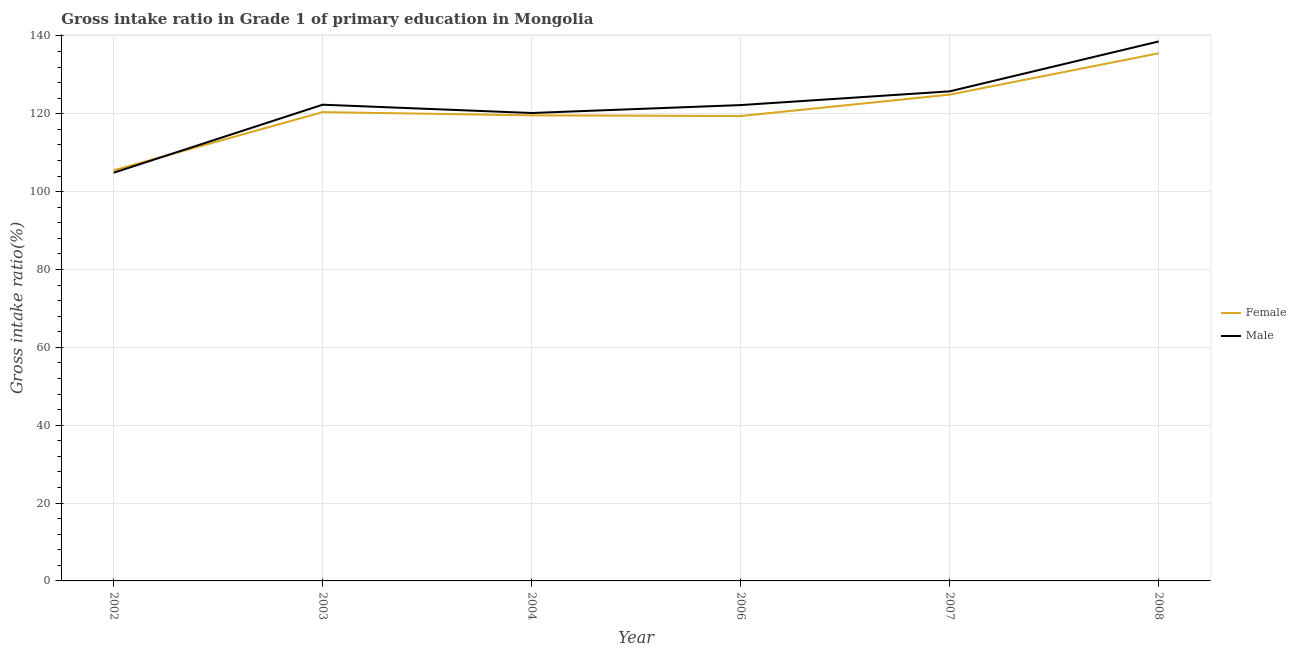How many different coloured lines are there?
Provide a short and direct response. 2. What is the gross intake ratio(male) in 2003?
Offer a terse response. 122.34. Across all years, what is the maximum gross intake ratio(male)?
Offer a terse response. 138.6. Across all years, what is the minimum gross intake ratio(male)?
Provide a short and direct response. 104.86. In which year was the gross intake ratio(female) maximum?
Ensure brevity in your answer.  2008. What is the total gross intake ratio(female) in the graph?
Ensure brevity in your answer.  725.45. What is the difference between the gross intake ratio(male) in 2002 and that in 2007?
Offer a very short reply. -20.91. What is the difference between the gross intake ratio(female) in 2008 and the gross intake ratio(male) in 2002?
Your answer should be compact. 30.69. What is the average gross intake ratio(male) per year?
Make the answer very short. 122.34. In the year 2004, what is the difference between the gross intake ratio(male) and gross intake ratio(female)?
Offer a terse response. 0.6. In how many years, is the gross intake ratio(female) greater than 100 %?
Ensure brevity in your answer.  6. What is the ratio of the gross intake ratio(male) in 2002 to that in 2003?
Your answer should be compact. 0.86. What is the difference between the highest and the second highest gross intake ratio(female)?
Give a very brief answer. 10.62. What is the difference between the highest and the lowest gross intake ratio(male)?
Provide a short and direct response. 33.73. In how many years, is the gross intake ratio(female) greater than the average gross intake ratio(female) taken over all years?
Provide a short and direct response. 2. Is the sum of the gross intake ratio(female) in 2006 and 2007 greater than the maximum gross intake ratio(male) across all years?
Offer a very short reply. Yes. Does the gross intake ratio(female) monotonically increase over the years?
Offer a terse response. No. Is the gross intake ratio(female) strictly greater than the gross intake ratio(male) over the years?
Give a very brief answer. No. Are the values on the major ticks of Y-axis written in scientific E-notation?
Give a very brief answer. No. Where does the legend appear in the graph?
Your response must be concise. Center right. How are the legend labels stacked?
Keep it short and to the point. Vertical. What is the title of the graph?
Offer a very short reply. Gross intake ratio in Grade 1 of primary education in Mongolia. What is the label or title of the X-axis?
Your response must be concise. Year. What is the label or title of the Y-axis?
Make the answer very short. Gross intake ratio(%). What is the Gross intake ratio(%) of Female in 2002?
Your answer should be very brief. 105.49. What is the Gross intake ratio(%) of Male in 2002?
Offer a terse response. 104.86. What is the Gross intake ratio(%) of Female in 2003?
Offer a very short reply. 120.43. What is the Gross intake ratio(%) in Male in 2003?
Keep it short and to the point. 122.34. What is the Gross intake ratio(%) of Female in 2004?
Your response must be concise. 119.61. What is the Gross intake ratio(%) in Male in 2004?
Your answer should be compact. 120.21. What is the Gross intake ratio(%) of Female in 2006?
Your answer should be compact. 119.43. What is the Gross intake ratio(%) of Male in 2006?
Ensure brevity in your answer.  122.25. What is the Gross intake ratio(%) of Female in 2007?
Offer a very short reply. 124.93. What is the Gross intake ratio(%) in Male in 2007?
Your answer should be very brief. 125.78. What is the Gross intake ratio(%) of Female in 2008?
Offer a very short reply. 135.55. What is the Gross intake ratio(%) of Male in 2008?
Offer a terse response. 138.6. Across all years, what is the maximum Gross intake ratio(%) of Female?
Offer a very short reply. 135.55. Across all years, what is the maximum Gross intake ratio(%) in Male?
Keep it short and to the point. 138.6. Across all years, what is the minimum Gross intake ratio(%) in Female?
Offer a very short reply. 105.49. Across all years, what is the minimum Gross intake ratio(%) in Male?
Provide a short and direct response. 104.86. What is the total Gross intake ratio(%) in Female in the graph?
Give a very brief answer. 725.45. What is the total Gross intake ratio(%) in Male in the graph?
Your response must be concise. 734.04. What is the difference between the Gross intake ratio(%) in Female in 2002 and that in 2003?
Provide a short and direct response. -14.95. What is the difference between the Gross intake ratio(%) in Male in 2002 and that in 2003?
Your answer should be compact. -17.48. What is the difference between the Gross intake ratio(%) of Female in 2002 and that in 2004?
Ensure brevity in your answer.  -14.12. What is the difference between the Gross intake ratio(%) of Male in 2002 and that in 2004?
Your answer should be compact. -15.35. What is the difference between the Gross intake ratio(%) in Female in 2002 and that in 2006?
Ensure brevity in your answer.  -13.95. What is the difference between the Gross intake ratio(%) of Male in 2002 and that in 2006?
Provide a short and direct response. -17.38. What is the difference between the Gross intake ratio(%) in Female in 2002 and that in 2007?
Your answer should be very brief. -19.44. What is the difference between the Gross intake ratio(%) of Male in 2002 and that in 2007?
Ensure brevity in your answer.  -20.91. What is the difference between the Gross intake ratio(%) in Female in 2002 and that in 2008?
Offer a terse response. -30.07. What is the difference between the Gross intake ratio(%) in Male in 2002 and that in 2008?
Your answer should be very brief. -33.73. What is the difference between the Gross intake ratio(%) in Female in 2003 and that in 2004?
Your answer should be compact. 0.82. What is the difference between the Gross intake ratio(%) in Male in 2003 and that in 2004?
Keep it short and to the point. 2.13. What is the difference between the Gross intake ratio(%) of Male in 2003 and that in 2006?
Provide a succinct answer. 0.1. What is the difference between the Gross intake ratio(%) of Female in 2003 and that in 2007?
Offer a very short reply. -4.49. What is the difference between the Gross intake ratio(%) in Male in 2003 and that in 2007?
Ensure brevity in your answer.  -3.43. What is the difference between the Gross intake ratio(%) of Female in 2003 and that in 2008?
Keep it short and to the point. -15.12. What is the difference between the Gross intake ratio(%) in Male in 2003 and that in 2008?
Give a very brief answer. -16.25. What is the difference between the Gross intake ratio(%) in Female in 2004 and that in 2006?
Keep it short and to the point. 0.18. What is the difference between the Gross intake ratio(%) of Male in 2004 and that in 2006?
Make the answer very short. -2.04. What is the difference between the Gross intake ratio(%) of Female in 2004 and that in 2007?
Provide a short and direct response. -5.32. What is the difference between the Gross intake ratio(%) of Male in 2004 and that in 2007?
Make the answer very short. -5.57. What is the difference between the Gross intake ratio(%) of Female in 2004 and that in 2008?
Your answer should be very brief. -15.94. What is the difference between the Gross intake ratio(%) of Male in 2004 and that in 2008?
Your response must be concise. -18.39. What is the difference between the Gross intake ratio(%) in Female in 2006 and that in 2007?
Provide a short and direct response. -5.5. What is the difference between the Gross intake ratio(%) in Male in 2006 and that in 2007?
Make the answer very short. -3.53. What is the difference between the Gross intake ratio(%) of Female in 2006 and that in 2008?
Give a very brief answer. -16.12. What is the difference between the Gross intake ratio(%) in Male in 2006 and that in 2008?
Provide a short and direct response. -16.35. What is the difference between the Gross intake ratio(%) of Female in 2007 and that in 2008?
Keep it short and to the point. -10.62. What is the difference between the Gross intake ratio(%) in Male in 2007 and that in 2008?
Provide a short and direct response. -12.82. What is the difference between the Gross intake ratio(%) in Female in 2002 and the Gross intake ratio(%) in Male in 2003?
Keep it short and to the point. -16.86. What is the difference between the Gross intake ratio(%) of Female in 2002 and the Gross intake ratio(%) of Male in 2004?
Ensure brevity in your answer.  -14.72. What is the difference between the Gross intake ratio(%) of Female in 2002 and the Gross intake ratio(%) of Male in 2006?
Your answer should be compact. -16.76. What is the difference between the Gross intake ratio(%) of Female in 2002 and the Gross intake ratio(%) of Male in 2007?
Make the answer very short. -20.29. What is the difference between the Gross intake ratio(%) of Female in 2002 and the Gross intake ratio(%) of Male in 2008?
Give a very brief answer. -33.11. What is the difference between the Gross intake ratio(%) in Female in 2003 and the Gross intake ratio(%) in Male in 2004?
Provide a succinct answer. 0.22. What is the difference between the Gross intake ratio(%) in Female in 2003 and the Gross intake ratio(%) in Male in 2006?
Make the answer very short. -1.81. What is the difference between the Gross intake ratio(%) of Female in 2003 and the Gross intake ratio(%) of Male in 2007?
Your response must be concise. -5.34. What is the difference between the Gross intake ratio(%) in Female in 2003 and the Gross intake ratio(%) in Male in 2008?
Give a very brief answer. -18.16. What is the difference between the Gross intake ratio(%) in Female in 2004 and the Gross intake ratio(%) in Male in 2006?
Your response must be concise. -2.64. What is the difference between the Gross intake ratio(%) of Female in 2004 and the Gross intake ratio(%) of Male in 2007?
Offer a terse response. -6.17. What is the difference between the Gross intake ratio(%) of Female in 2004 and the Gross intake ratio(%) of Male in 2008?
Your answer should be very brief. -18.98. What is the difference between the Gross intake ratio(%) of Female in 2006 and the Gross intake ratio(%) of Male in 2007?
Make the answer very short. -6.34. What is the difference between the Gross intake ratio(%) in Female in 2006 and the Gross intake ratio(%) in Male in 2008?
Keep it short and to the point. -19.16. What is the difference between the Gross intake ratio(%) of Female in 2007 and the Gross intake ratio(%) of Male in 2008?
Ensure brevity in your answer.  -13.67. What is the average Gross intake ratio(%) in Female per year?
Your answer should be very brief. 120.91. What is the average Gross intake ratio(%) of Male per year?
Keep it short and to the point. 122.34. In the year 2002, what is the difference between the Gross intake ratio(%) in Female and Gross intake ratio(%) in Male?
Give a very brief answer. 0.62. In the year 2003, what is the difference between the Gross intake ratio(%) of Female and Gross intake ratio(%) of Male?
Offer a very short reply. -1.91. In the year 2004, what is the difference between the Gross intake ratio(%) of Female and Gross intake ratio(%) of Male?
Make the answer very short. -0.6. In the year 2006, what is the difference between the Gross intake ratio(%) in Female and Gross intake ratio(%) in Male?
Give a very brief answer. -2.81. In the year 2007, what is the difference between the Gross intake ratio(%) of Female and Gross intake ratio(%) of Male?
Your response must be concise. -0.85. In the year 2008, what is the difference between the Gross intake ratio(%) of Female and Gross intake ratio(%) of Male?
Offer a terse response. -3.04. What is the ratio of the Gross intake ratio(%) of Female in 2002 to that in 2003?
Ensure brevity in your answer.  0.88. What is the ratio of the Gross intake ratio(%) in Female in 2002 to that in 2004?
Provide a succinct answer. 0.88. What is the ratio of the Gross intake ratio(%) of Male in 2002 to that in 2004?
Provide a succinct answer. 0.87. What is the ratio of the Gross intake ratio(%) of Female in 2002 to that in 2006?
Give a very brief answer. 0.88. What is the ratio of the Gross intake ratio(%) of Male in 2002 to that in 2006?
Ensure brevity in your answer.  0.86. What is the ratio of the Gross intake ratio(%) in Female in 2002 to that in 2007?
Offer a terse response. 0.84. What is the ratio of the Gross intake ratio(%) of Male in 2002 to that in 2007?
Your answer should be very brief. 0.83. What is the ratio of the Gross intake ratio(%) of Female in 2002 to that in 2008?
Offer a terse response. 0.78. What is the ratio of the Gross intake ratio(%) of Male in 2002 to that in 2008?
Ensure brevity in your answer.  0.76. What is the ratio of the Gross intake ratio(%) in Male in 2003 to that in 2004?
Keep it short and to the point. 1.02. What is the ratio of the Gross intake ratio(%) in Female in 2003 to that in 2006?
Your response must be concise. 1.01. What is the ratio of the Gross intake ratio(%) in Male in 2003 to that in 2006?
Provide a succinct answer. 1. What is the ratio of the Gross intake ratio(%) of Female in 2003 to that in 2007?
Keep it short and to the point. 0.96. What is the ratio of the Gross intake ratio(%) of Male in 2003 to that in 2007?
Your answer should be compact. 0.97. What is the ratio of the Gross intake ratio(%) of Female in 2003 to that in 2008?
Your answer should be very brief. 0.89. What is the ratio of the Gross intake ratio(%) in Male in 2003 to that in 2008?
Offer a terse response. 0.88. What is the ratio of the Gross intake ratio(%) of Male in 2004 to that in 2006?
Make the answer very short. 0.98. What is the ratio of the Gross intake ratio(%) of Female in 2004 to that in 2007?
Provide a succinct answer. 0.96. What is the ratio of the Gross intake ratio(%) of Male in 2004 to that in 2007?
Your response must be concise. 0.96. What is the ratio of the Gross intake ratio(%) of Female in 2004 to that in 2008?
Your response must be concise. 0.88. What is the ratio of the Gross intake ratio(%) of Male in 2004 to that in 2008?
Give a very brief answer. 0.87. What is the ratio of the Gross intake ratio(%) in Female in 2006 to that in 2007?
Offer a terse response. 0.96. What is the ratio of the Gross intake ratio(%) of Male in 2006 to that in 2007?
Provide a short and direct response. 0.97. What is the ratio of the Gross intake ratio(%) of Female in 2006 to that in 2008?
Offer a very short reply. 0.88. What is the ratio of the Gross intake ratio(%) of Male in 2006 to that in 2008?
Your answer should be very brief. 0.88. What is the ratio of the Gross intake ratio(%) in Female in 2007 to that in 2008?
Ensure brevity in your answer.  0.92. What is the ratio of the Gross intake ratio(%) in Male in 2007 to that in 2008?
Your response must be concise. 0.91. What is the difference between the highest and the second highest Gross intake ratio(%) in Female?
Your answer should be compact. 10.62. What is the difference between the highest and the second highest Gross intake ratio(%) in Male?
Offer a terse response. 12.82. What is the difference between the highest and the lowest Gross intake ratio(%) in Female?
Provide a succinct answer. 30.07. What is the difference between the highest and the lowest Gross intake ratio(%) in Male?
Make the answer very short. 33.73. 